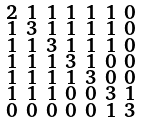Convert formula to latex. <formula><loc_0><loc_0><loc_500><loc_500>\begin{smallmatrix} 2 & 1 & 1 & 1 & 1 & 1 & 0 \\ 1 & 3 & 1 & 1 & 1 & 1 & 0 \\ 1 & 1 & 3 & 1 & 1 & 1 & 0 \\ 1 & 1 & 1 & 3 & 1 & 0 & 0 \\ 1 & 1 & 1 & 1 & 3 & 0 & 0 \\ 1 & 1 & 1 & 0 & 0 & 3 & 1 \\ 0 & 0 & 0 & 0 & 0 & 1 & 3 \end{smallmatrix}</formula> 